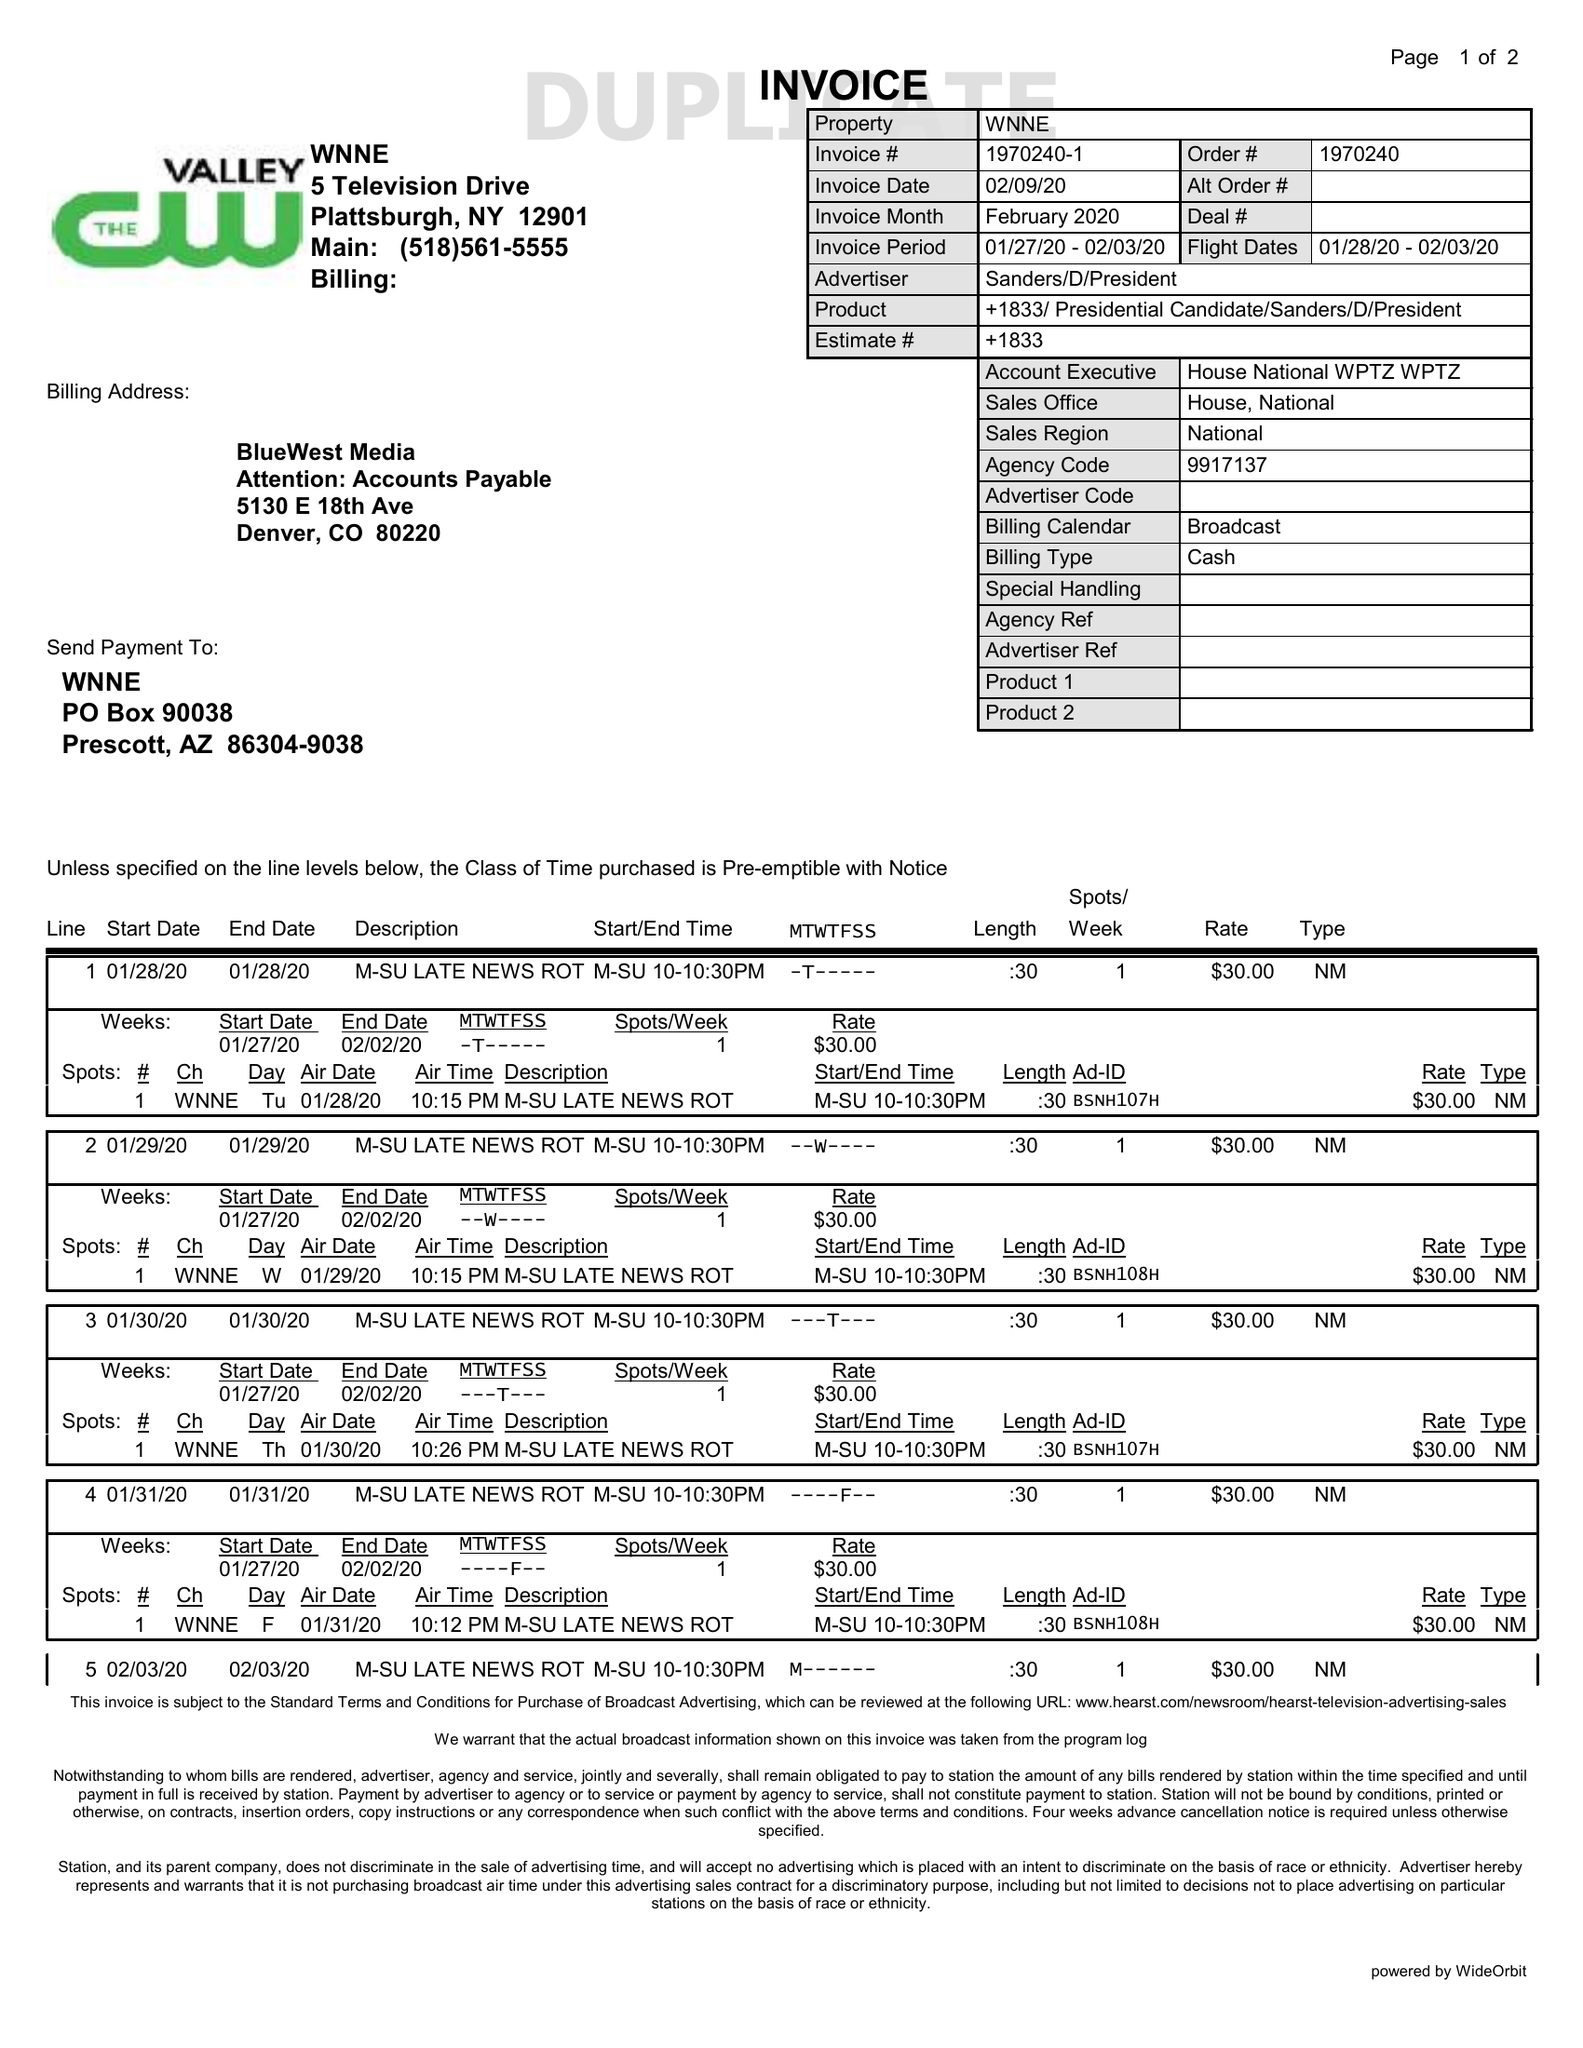What is the value for the flight_to?
Answer the question using a single word or phrase. 02/03/20 